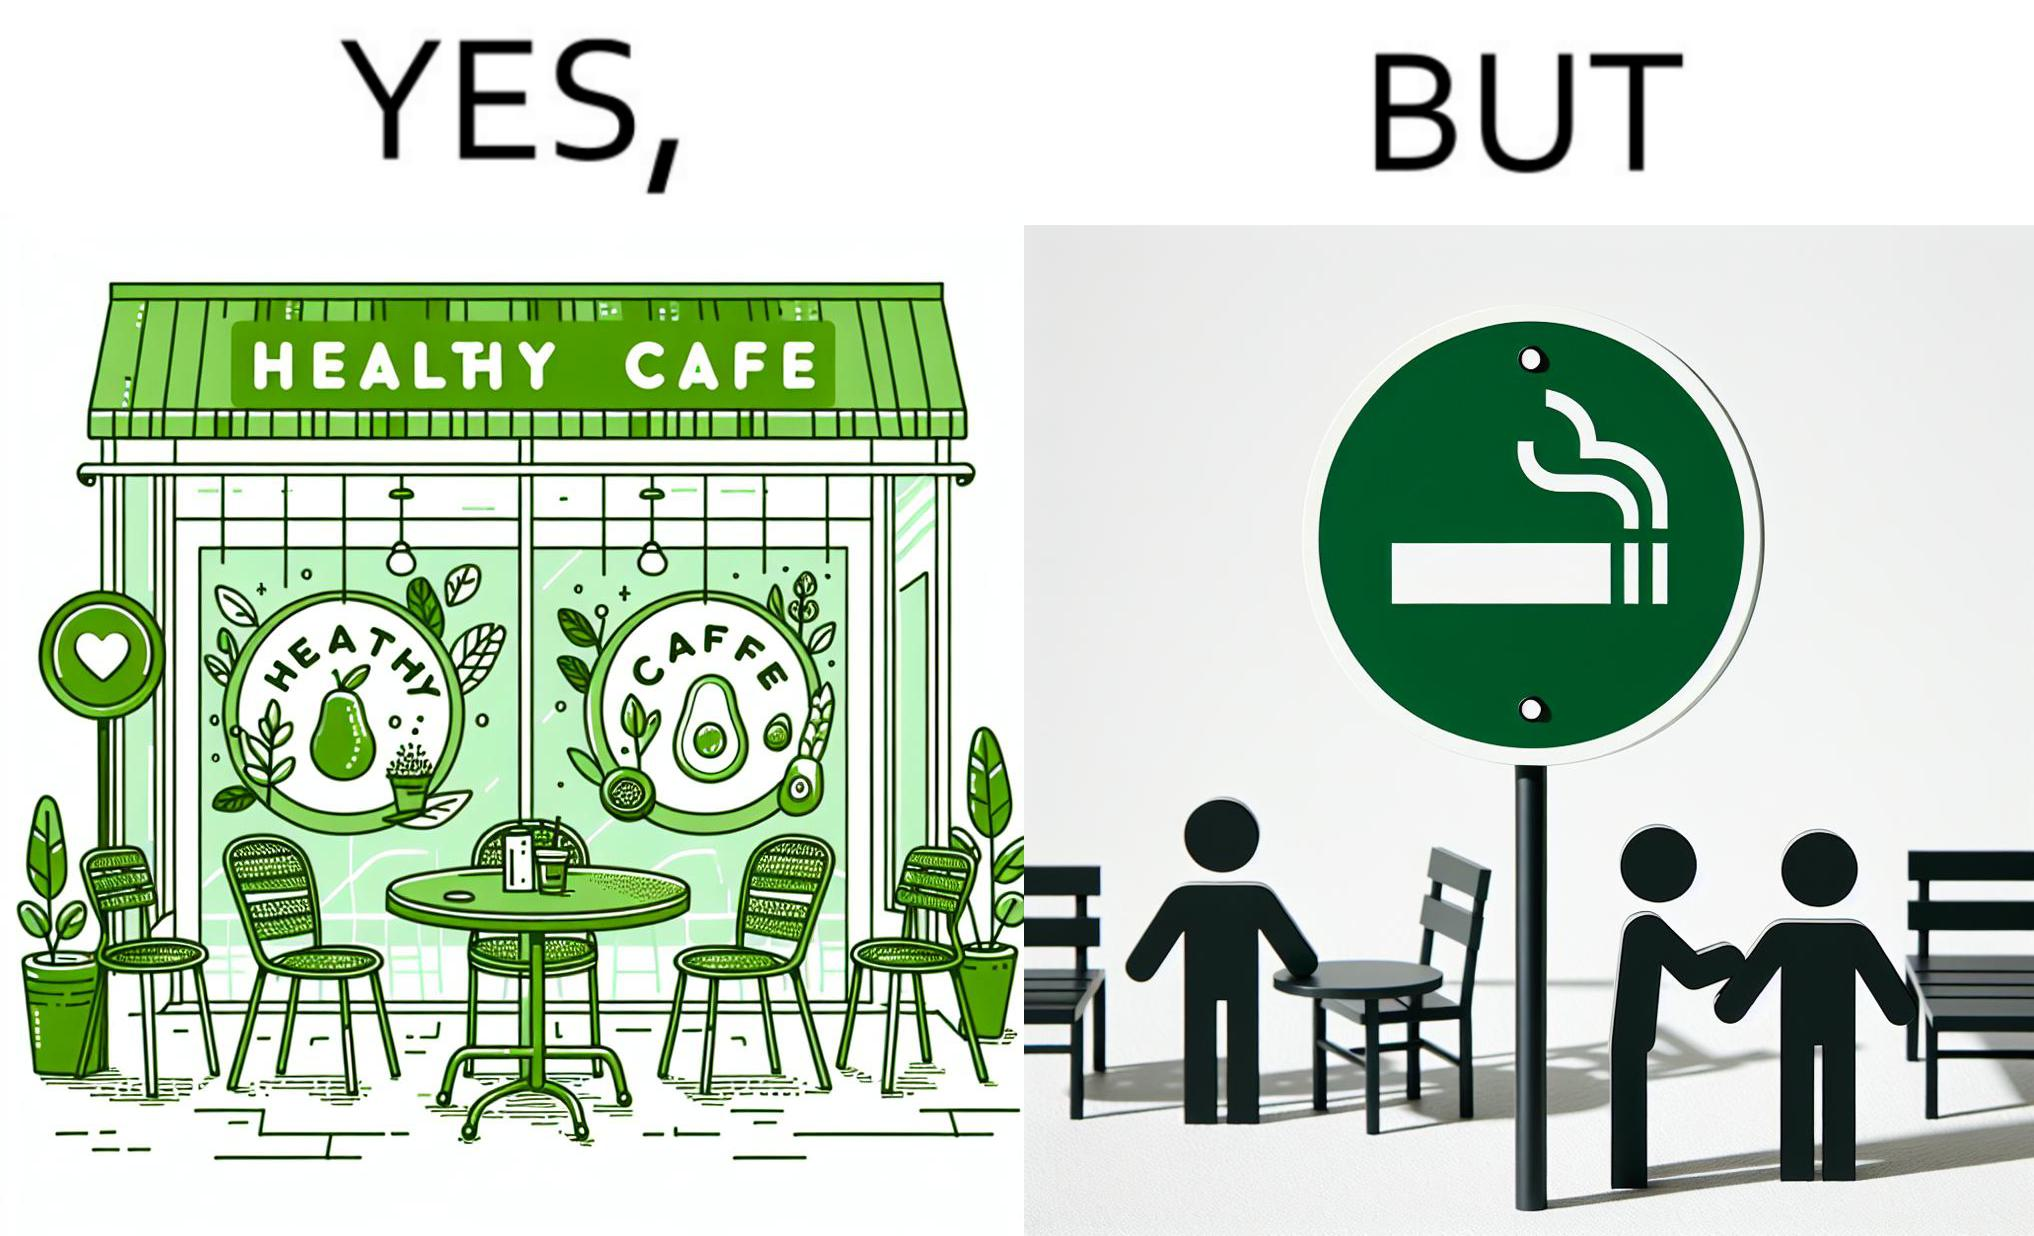Describe the satirical element in this image. This image is funny because an eatery that calls itself the "healthy" cafe also has a smoking area, which is not very "healthy". If it really was a healthy cafe, it would not have a smoking area as smoking is injurious to health. Satire on the behavior of humans - both those that operate this cafe who made the decision of allowing smoking and creating a designated smoking area, and those that visit this healthy cafe to become "healthy", but then also indulge in very unhealthy habits simultaneously. 